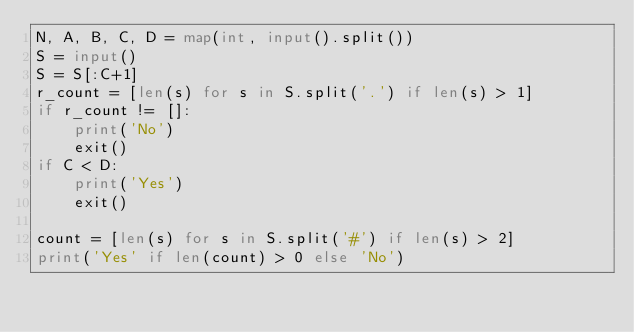Convert code to text. <code><loc_0><loc_0><loc_500><loc_500><_Python_>N, A, B, C, D = map(int, input().split())
S = input()
S = S[:C+1]
r_count = [len(s) for s in S.split('.') if len(s) > 1]
if r_count != []:
    print('No')
    exit()
if C < D:
    print('Yes')
    exit()

count = [len(s) for s in S.split('#') if len(s) > 2]
print('Yes' if len(count) > 0 else 'No')</code> 